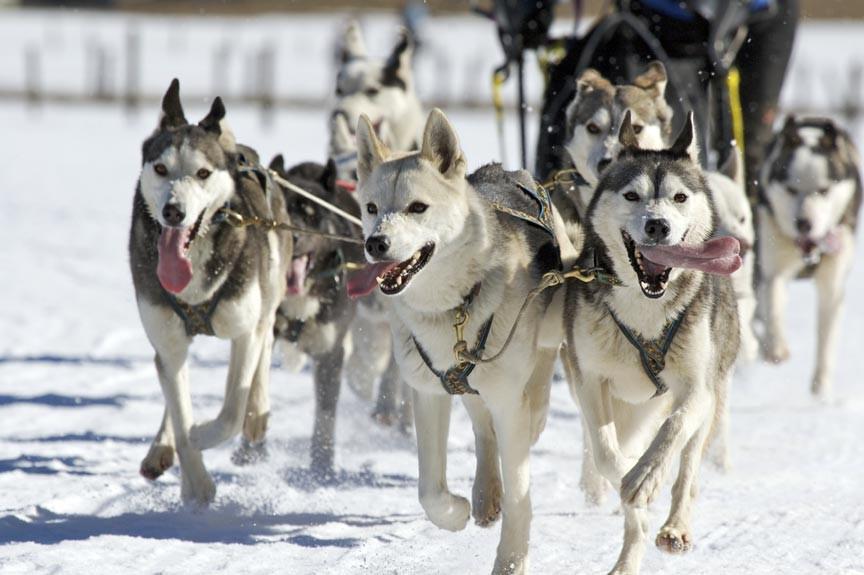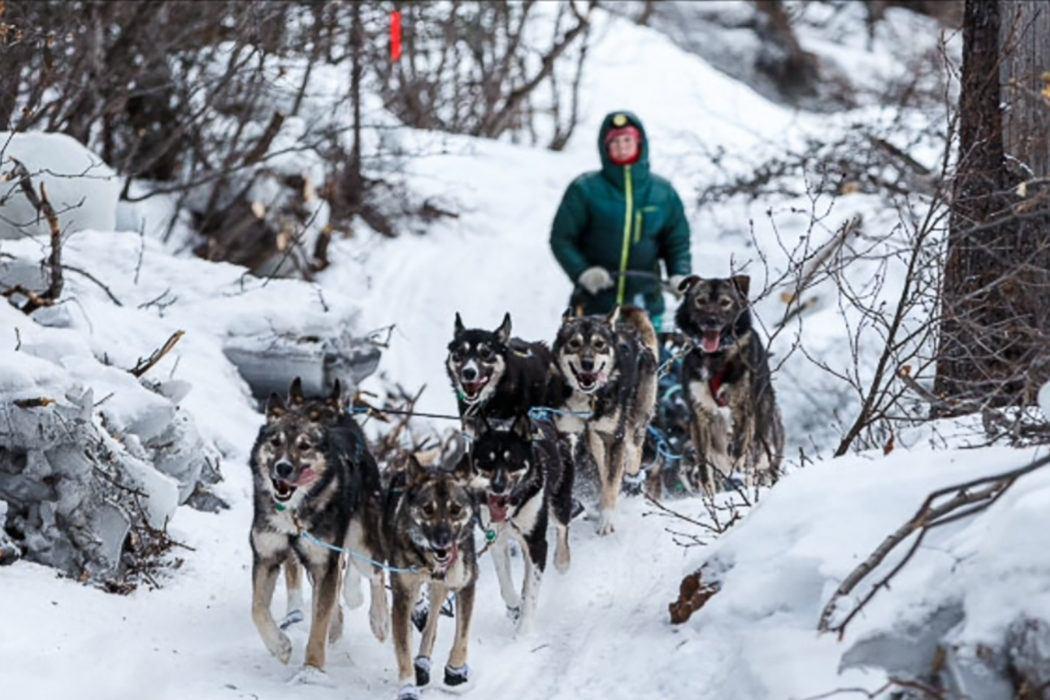The first image is the image on the left, the second image is the image on the right. For the images shown, is this caption "An image shows one dog team moving diagonally across the snow, with snow-covered evergreens in the background and no bystanders." true? Answer yes or no. No. The first image is the image on the left, the second image is the image on the right. Assess this claim about the two images: "Someone is wearing a vest with a number in at least one of the images.". Correct or not? Answer yes or no. No. 